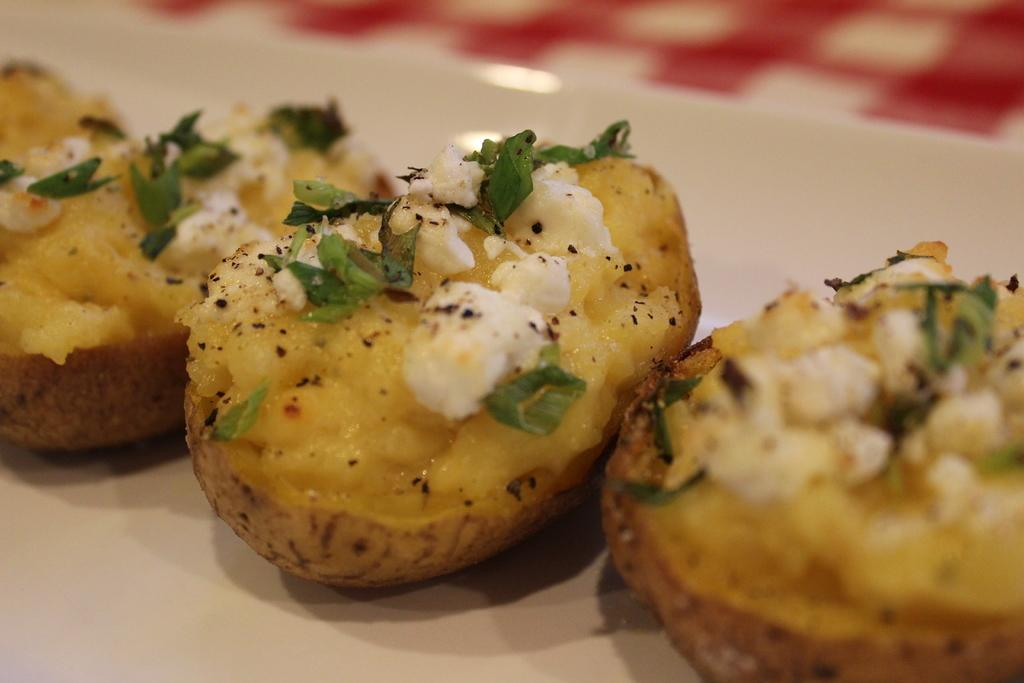What is the main subject of the image? The main subject of the image is food. Can you describe the background of the image? The background of the image is blurry. How many roses can be seen balancing on the edge of the plate in the image? There are no roses present in the image, and therefore no such balancing act can be observed. 